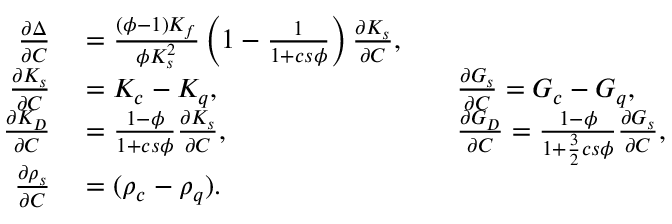Convert formula to latex. <formula><loc_0><loc_0><loc_500><loc_500>\begin{array} { r } { \begin{array} { r l r l } { \frac { \partial \Delta } { \partial C } } & = \frac { ( \phi - 1 ) K _ { f } } { \phi K _ { s } ^ { 2 } } \left ( 1 - \frac { 1 } { 1 + c s \phi } \right ) \frac { \partial K _ { s } } { \partial C } , } \\ { \frac { \partial K _ { s } } { \partial C } } & = K _ { c } - K _ { q } , \quad } & \frac { \partial G _ { s } } { \partial C } = G _ { c } - G _ { q } , } \\ { \frac { \partial K _ { D } } { \partial C } } & = \frac { 1 - \phi } { 1 + c s \phi } \frac { \partial K _ { s } } { \partial C } , \quad } & \frac { \partial G _ { D } } { \partial C } = \frac { 1 - \phi } { 1 + \frac { 3 } { 2 } c s \phi } \frac { \partial G _ { s } } { \partial C } , } \\ { \frac { \partial \rho _ { s } } { \partial C } } & = ( \rho _ { c } - \rho _ { q } ) . } \end{array} } \end{array}</formula> 